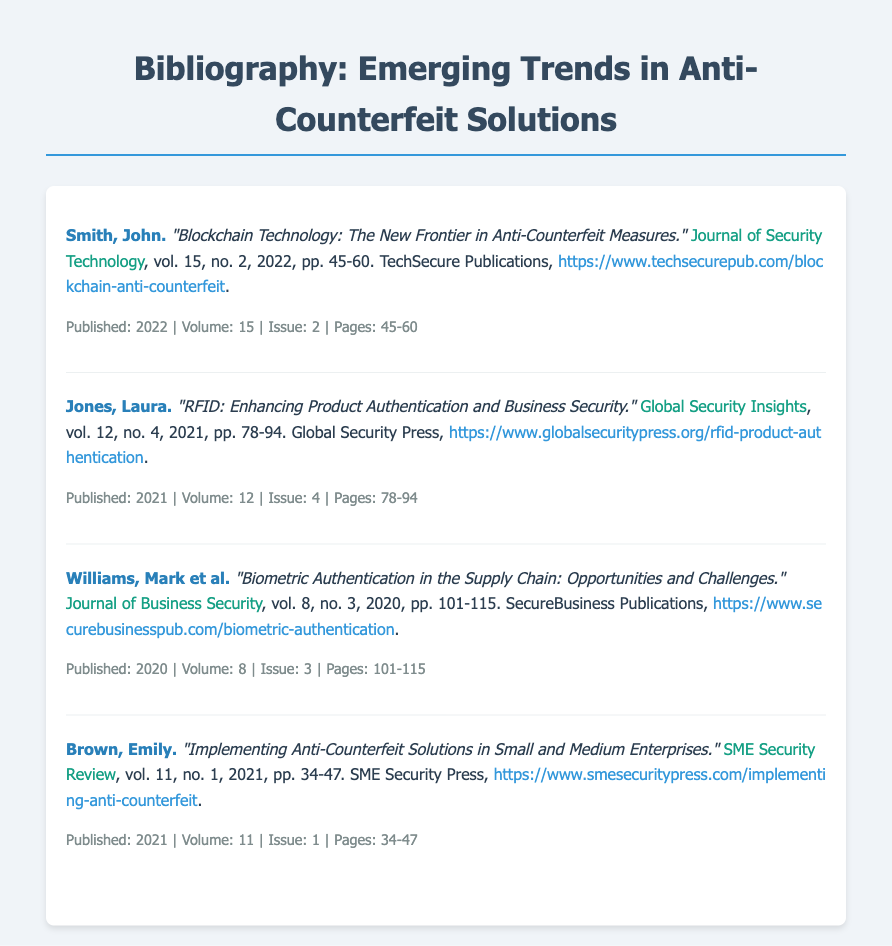What is the title of the first entry? The title of the first entry is found in the citation and is "Blockchain Technology: The New Frontier in Anti-Counterfeit Measures."
Answer: "Blockchain Technology: The New Frontier in Anti-Counterfeit Measures." Who is the author of the second entry? The author's name for the second entry is listed at the beginning of the citation.
Answer: Laura Jones What volume number is associated with the last entry? The volume number is stated in the citation of the last entry, which is Volume 11.
Answer: 11 What publication year is indicated for the article on RFID? The year associated with the RFID article can be found in its citation.
Answer: 2021 Which journal published the article written by Emily Brown? The name of the journal is provided in the citation of Emily Brown's article.
Answer: SME Security Review How many pages does the article by Mark Williams et al. cover? The page range for the article is mentioned in the citation.
Answer: 101-115 What is the URL for the article about blockchain technology? The URL is provided in the citation of the blockchain technology entry.
Answer: https://www.techsecurepub.com/blockchain-anti-counterfeit What is the main focus of the article by Brown? The focus is indicated in the title of the article and in the citation.
Answer: Implementing Anti-Counterfeit Solutions in Small and Medium Enterprises 